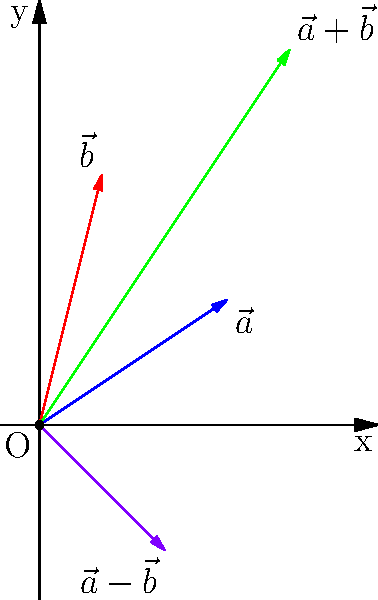In the given 2D coordinate system, vectors $\vec{a}$ and $\vec{b}$ are represented by blue and red arrows respectively. The green arrow represents $\vec{a} + \vec{b}$, and the purple arrow represents $\vec{a} - \vec{b}$. If $\vec{a} = (3,2)$ and $\vec{b} = (1,4)$, calculate the coordinates of the tip of the purple arrow $(\vec{a} - \vec{b})$. To find the coordinates of the tip of the purple arrow, which represents $\vec{a} - \vec{b}$, we need to perform vector subtraction:

1) First, recall that $\vec{a} = (3,2)$ and $\vec{b} = (1,4)$

2) Vector subtraction is performed component-wise:
   $\vec{a} - \vec{b} = (a_x - b_x, a_y - b_y)$

3) Substituting the values:
   $\vec{a} - \vec{b} = (3 - 1, 2 - 4)$

4) Simplifying:
   $\vec{a} - \vec{b} = (2, -2)$

Therefore, the coordinates of the tip of the purple arrow are $(2, -2)$.
Answer: $(2, -2)$ 